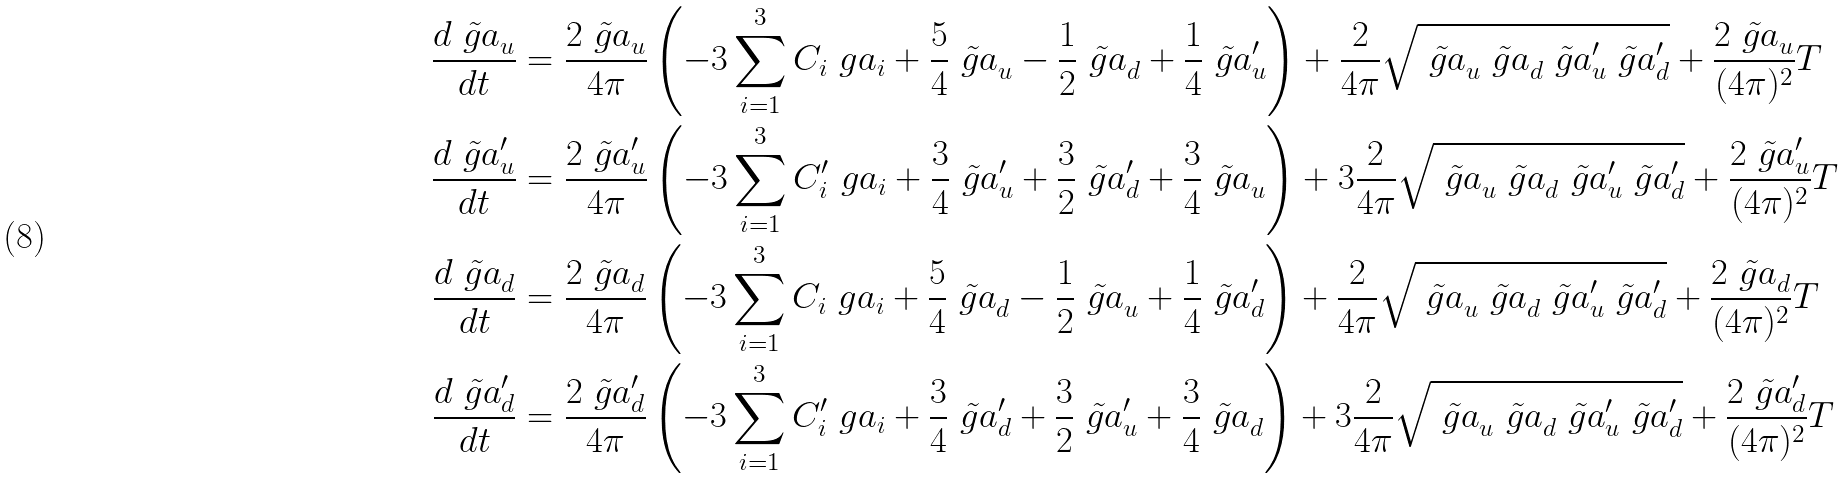Convert formula to latex. <formula><loc_0><loc_0><loc_500><loc_500>\frac { d \tilde { \ g a } _ { u } } { d t } & = \frac { 2 \tilde { \ g a } _ { u } } { 4 \pi } \left ( - 3 \sum _ { i = 1 } ^ { 3 } C _ { i } \ g a _ { i } + \frac { 5 } { 4 } \tilde { \ g a } _ { u } - \frac { 1 } { 2 } \tilde { \ g a } _ { d } + \frac { 1 } { 4 } \tilde { \ g a } _ { u } ^ { \prime } \right ) + \frac { 2 } { 4 \pi } \sqrt { \tilde { \ g a } _ { u } \tilde { \ g a } _ { d } \tilde { \ g a } _ { u } ^ { \prime } \tilde { \ g a } _ { d } ^ { \prime } } + \frac { 2 \tilde { \ g a } _ { u } } { ( 4 \pi ) ^ { 2 } } T \\ \frac { d \tilde { \ g a } _ { u } ^ { \prime } } { d t } & = \frac { 2 \tilde { \ g a } _ { u } ^ { \prime } } { 4 \pi } \left ( - 3 \sum _ { i = 1 } ^ { 3 } C _ { i } ^ { \prime } \ g a _ { i } + \frac { 3 } { 4 } \tilde { \ g a } _ { u } ^ { \prime } + \frac { 3 } { 2 } \tilde { \ g a } _ { d } ^ { \prime } + \frac { 3 } { 4 } \tilde { \ g a } _ { u } \right ) + 3 \frac { 2 } { 4 \pi } \sqrt { \tilde { \ g a } _ { u } \tilde { \ g a } _ { d } \tilde { \ g a } _ { u } ^ { \prime } \tilde { \ g a } _ { d } ^ { \prime } } + \frac { 2 \tilde { \ g a } _ { u } ^ { \prime } } { ( 4 \pi ) ^ { 2 } } T \\ \frac { d \tilde { \ g a } _ { d } } { d t } & = \frac { 2 \tilde { \ g a } _ { d } } { 4 \pi } \left ( - 3 \sum _ { i = 1 } ^ { 3 } C _ { i } \ g a _ { i } + \frac { 5 } { 4 } \tilde { \ g a } _ { d } - \frac { 1 } { 2 } \tilde { \ g a } _ { u } + \frac { 1 } { 4 } \tilde { \ g a } _ { d } ^ { \prime } \right ) + \frac { 2 } { 4 \pi } \sqrt { \tilde { \ g a } _ { u } \tilde { \ g a } _ { d } \tilde { \ g a } _ { u } ^ { \prime } \tilde { \ g a } _ { d } ^ { \prime } } + \frac { 2 \tilde { \ g a } _ { d } } { ( 4 \pi ) ^ { 2 } } T \\ \frac { d \tilde { \ g a } _ { d } ^ { \prime } } { d t } & = \frac { 2 \tilde { \ g a } _ { d } ^ { \prime } } { 4 \pi } \left ( - 3 \sum _ { i = 1 } ^ { 3 } C _ { i } ^ { \prime } \ g a _ { i } + \frac { 3 } { 4 } \tilde { \ g a } _ { d } ^ { \prime } + \frac { 3 } { 2 } \tilde { \ g a } _ { u } ^ { \prime } + \frac { 3 } { 4 } \tilde { \ g a } _ { d } \right ) + 3 \frac { 2 } { 4 \pi } \sqrt { \tilde { \ g a } _ { u } \tilde { \ g a } _ { d } \tilde { \ g a } _ { u } ^ { \prime } \tilde { \ g a } _ { d } ^ { \prime } } + \frac { 2 \tilde { \ g a } _ { d } ^ { \prime } } { ( 4 \pi ) ^ { 2 } } T</formula> 